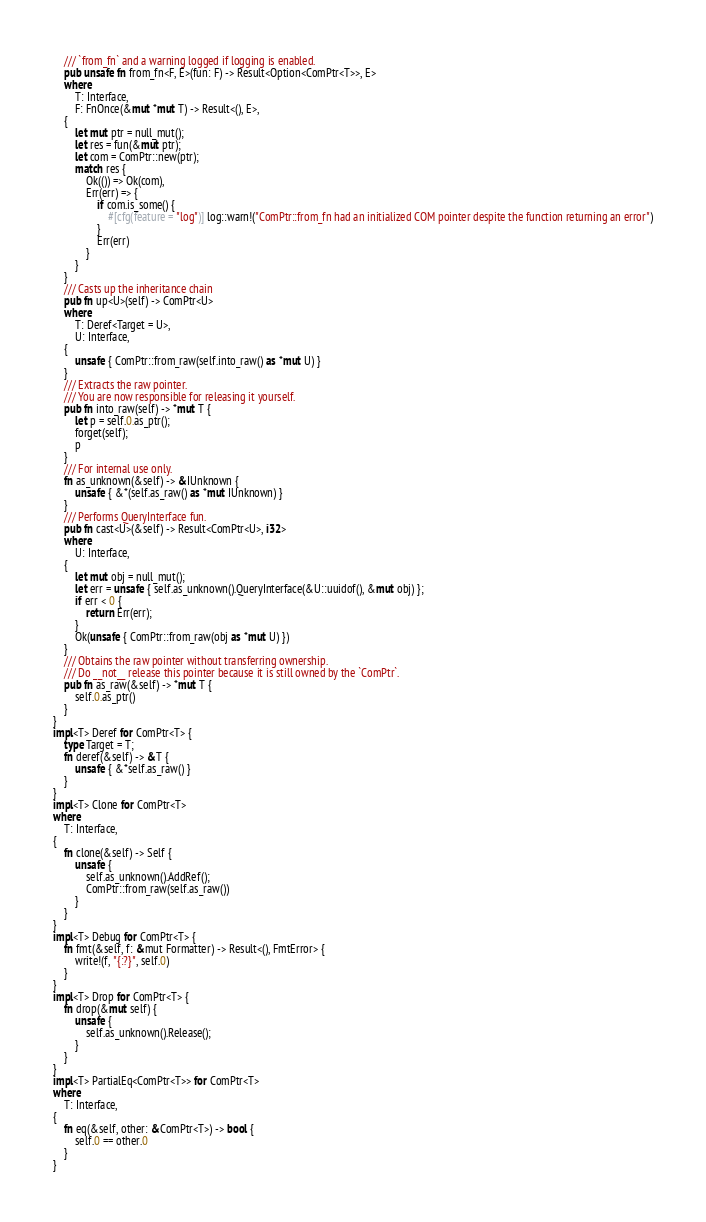Convert code to text. <code><loc_0><loc_0><loc_500><loc_500><_Rust_>    /// `from_fn` and a warning logged if logging is enabled.
    pub unsafe fn from_fn<F, E>(fun: F) -> Result<Option<ComPtr<T>>, E>
    where
        T: Interface,
        F: FnOnce(&mut *mut T) -> Result<(), E>,
    {
        let mut ptr = null_mut();
        let res = fun(&mut ptr);
        let com = ComPtr::new(ptr);
        match res {
            Ok(()) => Ok(com),
            Err(err) => {
                if com.is_some() {
                    #[cfg(feature = "log")] log::warn!("ComPtr::from_fn had an initialized COM pointer despite the function returning an error")
                }
                Err(err)
            }
        }
    }
    /// Casts up the inheritance chain
    pub fn up<U>(self) -> ComPtr<U>
    where
        T: Deref<Target = U>,
        U: Interface,
    {
        unsafe { ComPtr::from_raw(self.into_raw() as *mut U) }
    }
    /// Extracts the raw pointer.
    /// You are now responsible for releasing it yourself.
    pub fn into_raw(self) -> *mut T {
        let p = self.0.as_ptr();
        forget(self);
        p
    }
    /// For internal use only.
    fn as_unknown(&self) -> &IUnknown {
        unsafe { &*(self.as_raw() as *mut IUnknown) }
    }
    /// Performs QueryInterface fun.
    pub fn cast<U>(&self) -> Result<ComPtr<U>, i32>
    where
        U: Interface,
    {
        let mut obj = null_mut();
        let err = unsafe { self.as_unknown().QueryInterface(&U::uuidof(), &mut obj) };
        if err < 0 {
            return Err(err);
        }
        Ok(unsafe { ComPtr::from_raw(obj as *mut U) })
    }
    /// Obtains the raw pointer without transferring ownership.
    /// Do __not__ release this pointer because it is still owned by the `ComPtr`.
    pub fn as_raw(&self) -> *mut T {
        self.0.as_ptr()
    }
}
impl<T> Deref for ComPtr<T> {
    type Target = T;
    fn deref(&self) -> &T {
        unsafe { &*self.as_raw() }
    }
}
impl<T> Clone for ComPtr<T>
where
    T: Interface,
{
    fn clone(&self) -> Self {
        unsafe {
            self.as_unknown().AddRef();
            ComPtr::from_raw(self.as_raw())
        }
    }
}
impl<T> Debug for ComPtr<T> {
    fn fmt(&self, f: &mut Formatter) -> Result<(), FmtError> {
        write!(f, "{:?}", self.0)
    }
}
impl<T> Drop for ComPtr<T> {
    fn drop(&mut self) {
        unsafe {
            self.as_unknown().Release();
        }
    }
}
impl<T> PartialEq<ComPtr<T>> for ComPtr<T>
where
    T: Interface,
{
    fn eq(&self, other: &ComPtr<T>) -> bool {
        self.0 == other.0
    }
}
</code> 